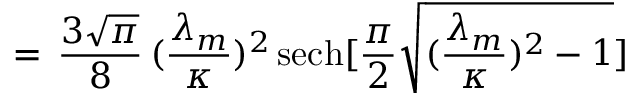Convert formula to latex. <formula><loc_0><loc_0><loc_500><loc_500>= \, \frac { 3 \sqrt { \pi } } { 8 } \, ( \frac { \lambda _ { m } } { \kappa } ) ^ { 2 } \, s e c h [ \frac { \pi } { 2 } \sqrt { ( \frac { \lambda _ { m } } { \kappa } ) ^ { 2 } - 1 } ]</formula> 